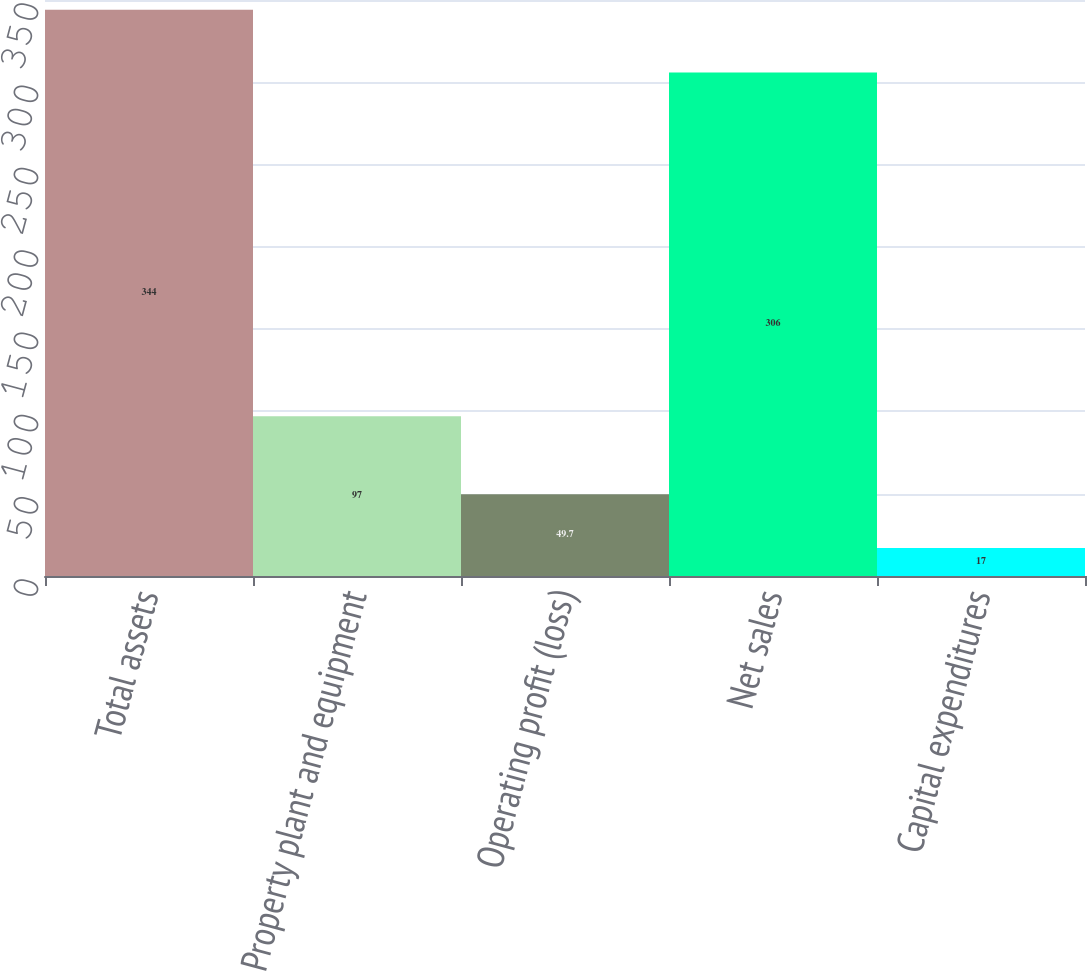Convert chart. <chart><loc_0><loc_0><loc_500><loc_500><bar_chart><fcel>Total assets<fcel>Property plant and equipment<fcel>Operating profit (loss)<fcel>Net sales<fcel>Capital expenditures<nl><fcel>344<fcel>97<fcel>49.7<fcel>306<fcel>17<nl></chart> 